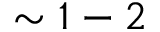<formula> <loc_0><loc_0><loc_500><loc_500>\sim 1 - 2</formula> 